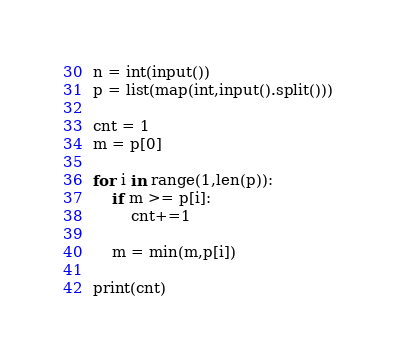<code> <loc_0><loc_0><loc_500><loc_500><_Python_>n = int(input())
p = list(map(int,input().split()))

cnt = 1
m = p[0]

for i in range(1,len(p)):
    if m >= p[i]:
        cnt+=1
    
    m = min(m,p[i])
    
print(cnt)</code> 